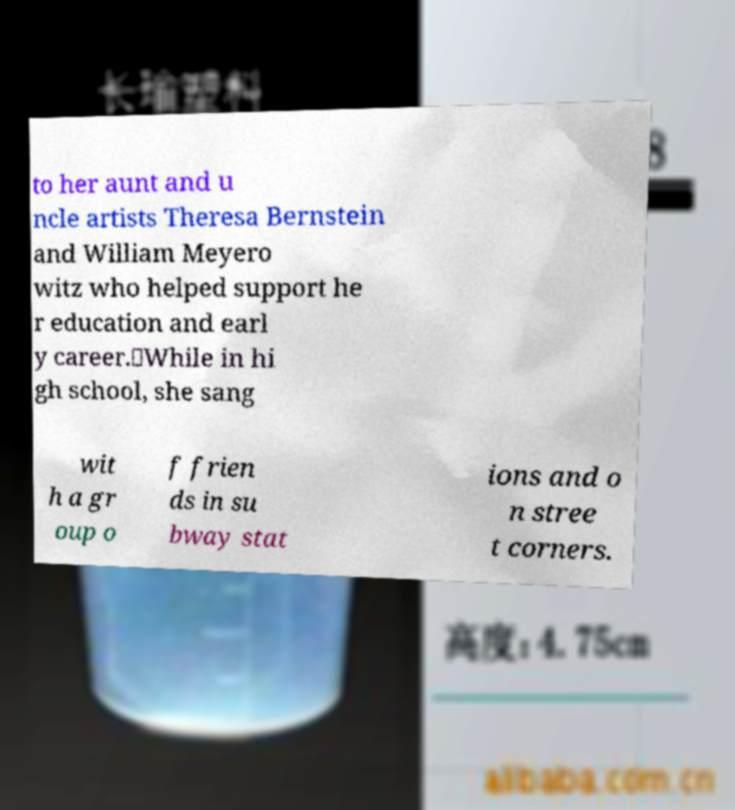Could you assist in decoding the text presented in this image and type it out clearly? to her aunt and u ncle artists Theresa Bernstein and William Meyero witz who helped support he r education and earl y career.。While in hi gh school, she sang wit h a gr oup o f frien ds in su bway stat ions and o n stree t corners. 